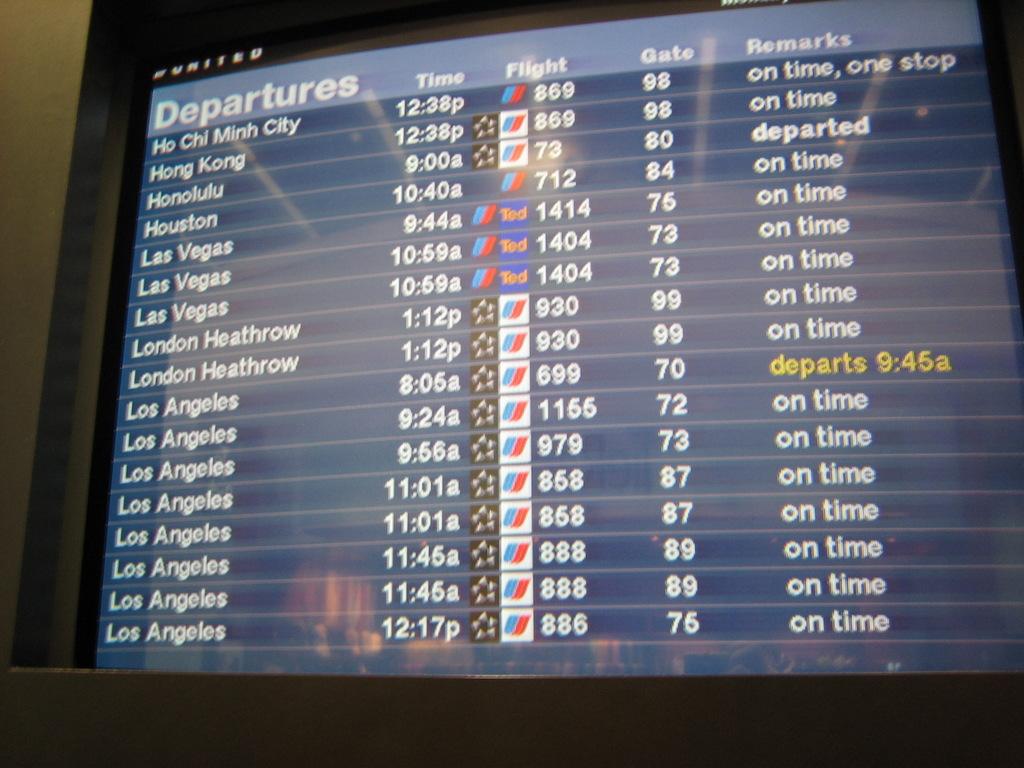What gate does the flight to houston #712 board?
Make the answer very short. 84. What is the name of the first city?
Your response must be concise. Ho chi minh city. 